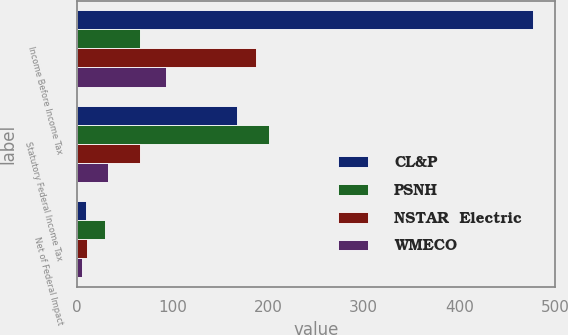<chart> <loc_0><loc_0><loc_500><loc_500><stacked_bar_chart><ecel><fcel>Income Before Income Tax<fcel>Statutory Federal Income Tax<fcel>Net of Federal Impact<nl><fcel>CL&P<fcel>476.8<fcel>166.9<fcel>9.2<nl><fcel>PSNH<fcel>65.6<fcel>200.4<fcel>29.6<nl><fcel>NSTAR  Electric<fcel>187.5<fcel>65.6<fcel>9.9<nl><fcel>WMECO<fcel>93.5<fcel>32.7<fcel>4.9<nl></chart> 